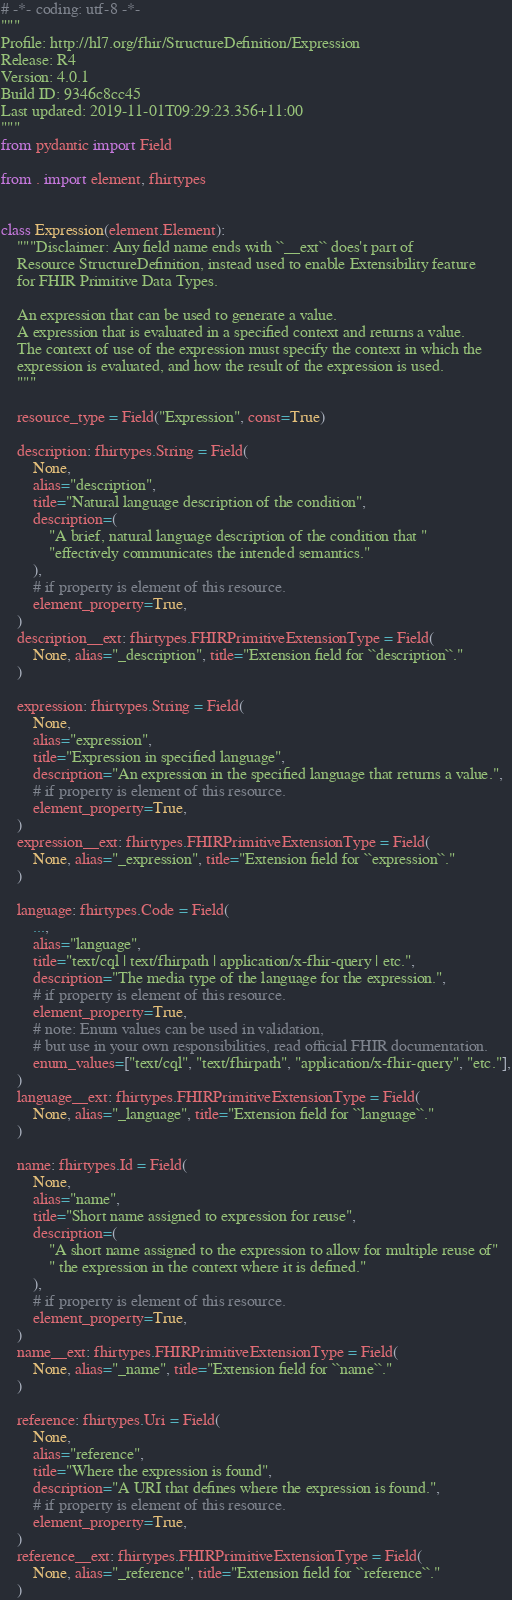Convert code to text. <code><loc_0><loc_0><loc_500><loc_500><_Python_># -*- coding: utf-8 -*-
"""
Profile: http://hl7.org/fhir/StructureDefinition/Expression
Release: R4
Version: 4.0.1
Build ID: 9346c8cc45
Last updated: 2019-11-01T09:29:23.356+11:00
"""
from pydantic import Field

from . import element, fhirtypes


class Expression(element.Element):
    """Disclaimer: Any field name ends with ``__ext`` does't part of
    Resource StructureDefinition, instead used to enable Extensibility feature
    for FHIR Primitive Data Types.

    An expression that can be used to generate a value.
    A expression that is evaluated in a specified context and returns a value.
    The context of use of the expression must specify the context in which the
    expression is evaluated, and how the result of the expression is used.
    """

    resource_type = Field("Expression", const=True)

    description: fhirtypes.String = Field(
        None,
        alias="description",
        title="Natural language description of the condition",
        description=(
            "A brief, natural language description of the condition that "
            "effectively communicates the intended semantics."
        ),
        # if property is element of this resource.
        element_property=True,
    )
    description__ext: fhirtypes.FHIRPrimitiveExtensionType = Field(
        None, alias="_description", title="Extension field for ``description``."
    )

    expression: fhirtypes.String = Field(
        None,
        alias="expression",
        title="Expression in specified language",
        description="An expression in the specified language that returns a value.",
        # if property is element of this resource.
        element_property=True,
    )
    expression__ext: fhirtypes.FHIRPrimitiveExtensionType = Field(
        None, alias="_expression", title="Extension field for ``expression``."
    )

    language: fhirtypes.Code = Field(
        ...,
        alias="language",
        title="text/cql | text/fhirpath | application/x-fhir-query | etc.",
        description="The media type of the language for the expression.",
        # if property is element of this resource.
        element_property=True,
        # note: Enum values can be used in validation,
        # but use in your own responsibilities, read official FHIR documentation.
        enum_values=["text/cql", "text/fhirpath", "application/x-fhir-query", "etc."],
    )
    language__ext: fhirtypes.FHIRPrimitiveExtensionType = Field(
        None, alias="_language", title="Extension field for ``language``."
    )

    name: fhirtypes.Id = Field(
        None,
        alias="name",
        title="Short name assigned to expression for reuse",
        description=(
            "A short name assigned to the expression to allow for multiple reuse of"
            " the expression in the context where it is defined."
        ),
        # if property is element of this resource.
        element_property=True,
    )
    name__ext: fhirtypes.FHIRPrimitiveExtensionType = Field(
        None, alias="_name", title="Extension field for ``name``."
    )

    reference: fhirtypes.Uri = Field(
        None,
        alias="reference",
        title="Where the expression is found",
        description="A URI that defines where the expression is found.",
        # if property is element of this resource.
        element_property=True,
    )
    reference__ext: fhirtypes.FHIRPrimitiveExtensionType = Field(
        None, alias="_reference", title="Extension field for ``reference``."
    )
</code> 